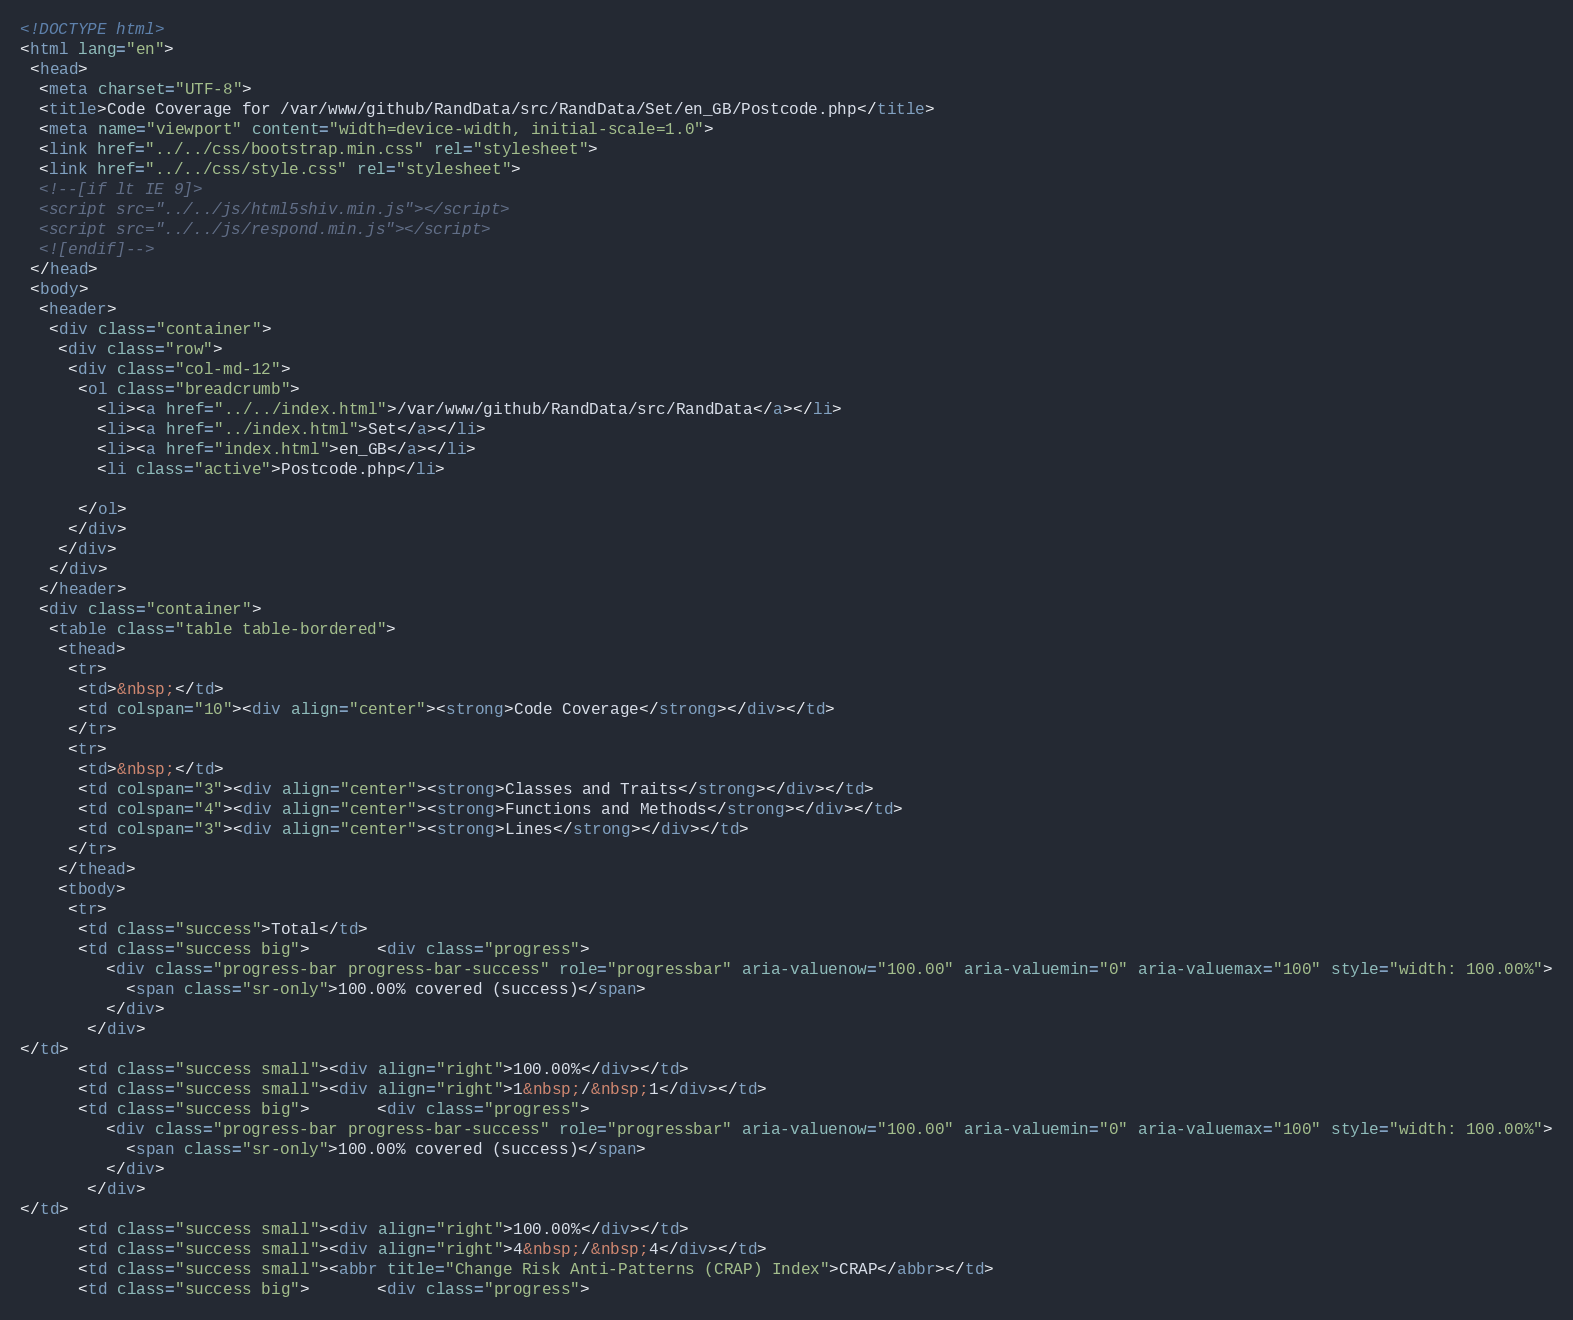Convert code to text. <code><loc_0><loc_0><loc_500><loc_500><_HTML_><!DOCTYPE html>
<html lang="en">
 <head>
  <meta charset="UTF-8">
  <title>Code Coverage for /var/www/github/RandData/src/RandData/Set/en_GB/Postcode.php</title>
  <meta name="viewport" content="width=device-width, initial-scale=1.0">
  <link href="../../css/bootstrap.min.css" rel="stylesheet">
  <link href="../../css/style.css" rel="stylesheet">
  <!--[if lt IE 9]>
  <script src="../../js/html5shiv.min.js"></script>
  <script src="../../js/respond.min.js"></script>
  <![endif]-->
 </head>
 <body>
  <header>
   <div class="container">
    <div class="row">
     <div class="col-md-12">
      <ol class="breadcrumb">
        <li><a href="../../index.html">/var/www/github/RandData/src/RandData</a></li>
        <li><a href="../index.html">Set</a></li>
        <li><a href="index.html">en_GB</a></li>
        <li class="active">Postcode.php</li>

      </ol>
     </div>
    </div>
   </div>
  </header>
  <div class="container">
   <table class="table table-bordered">
    <thead>
     <tr>
      <td>&nbsp;</td>
      <td colspan="10"><div align="center"><strong>Code Coverage</strong></div></td>
     </tr>
     <tr>
      <td>&nbsp;</td>
      <td colspan="3"><div align="center"><strong>Classes and Traits</strong></div></td>
      <td colspan="4"><div align="center"><strong>Functions and Methods</strong></div></td>
      <td colspan="3"><div align="center"><strong>Lines</strong></div></td>
     </tr>
    </thead>
    <tbody>
     <tr>
      <td class="success">Total</td>
      <td class="success big">       <div class="progress">
         <div class="progress-bar progress-bar-success" role="progressbar" aria-valuenow="100.00" aria-valuemin="0" aria-valuemax="100" style="width: 100.00%">
           <span class="sr-only">100.00% covered (success)</span>
         </div>
       </div>
</td>
      <td class="success small"><div align="right">100.00%</div></td>
      <td class="success small"><div align="right">1&nbsp;/&nbsp;1</div></td>
      <td class="success big">       <div class="progress">
         <div class="progress-bar progress-bar-success" role="progressbar" aria-valuenow="100.00" aria-valuemin="0" aria-valuemax="100" style="width: 100.00%">
           <span class="sr-only">100.00% covered (success)</span>
         </div>
       </div>
</td>
      <td class="success small"><div align="right">100.00%</div></td>
      <td class="success small"><div align="right">4&nbsp;/&nbsp;4</div></td>
      <td class="success small"><abbr title="Change Risk Anti-Patterns (CRAP) Index">CRAP</abbr></td>
      <td class="success big">       <div class="progress"></code> 